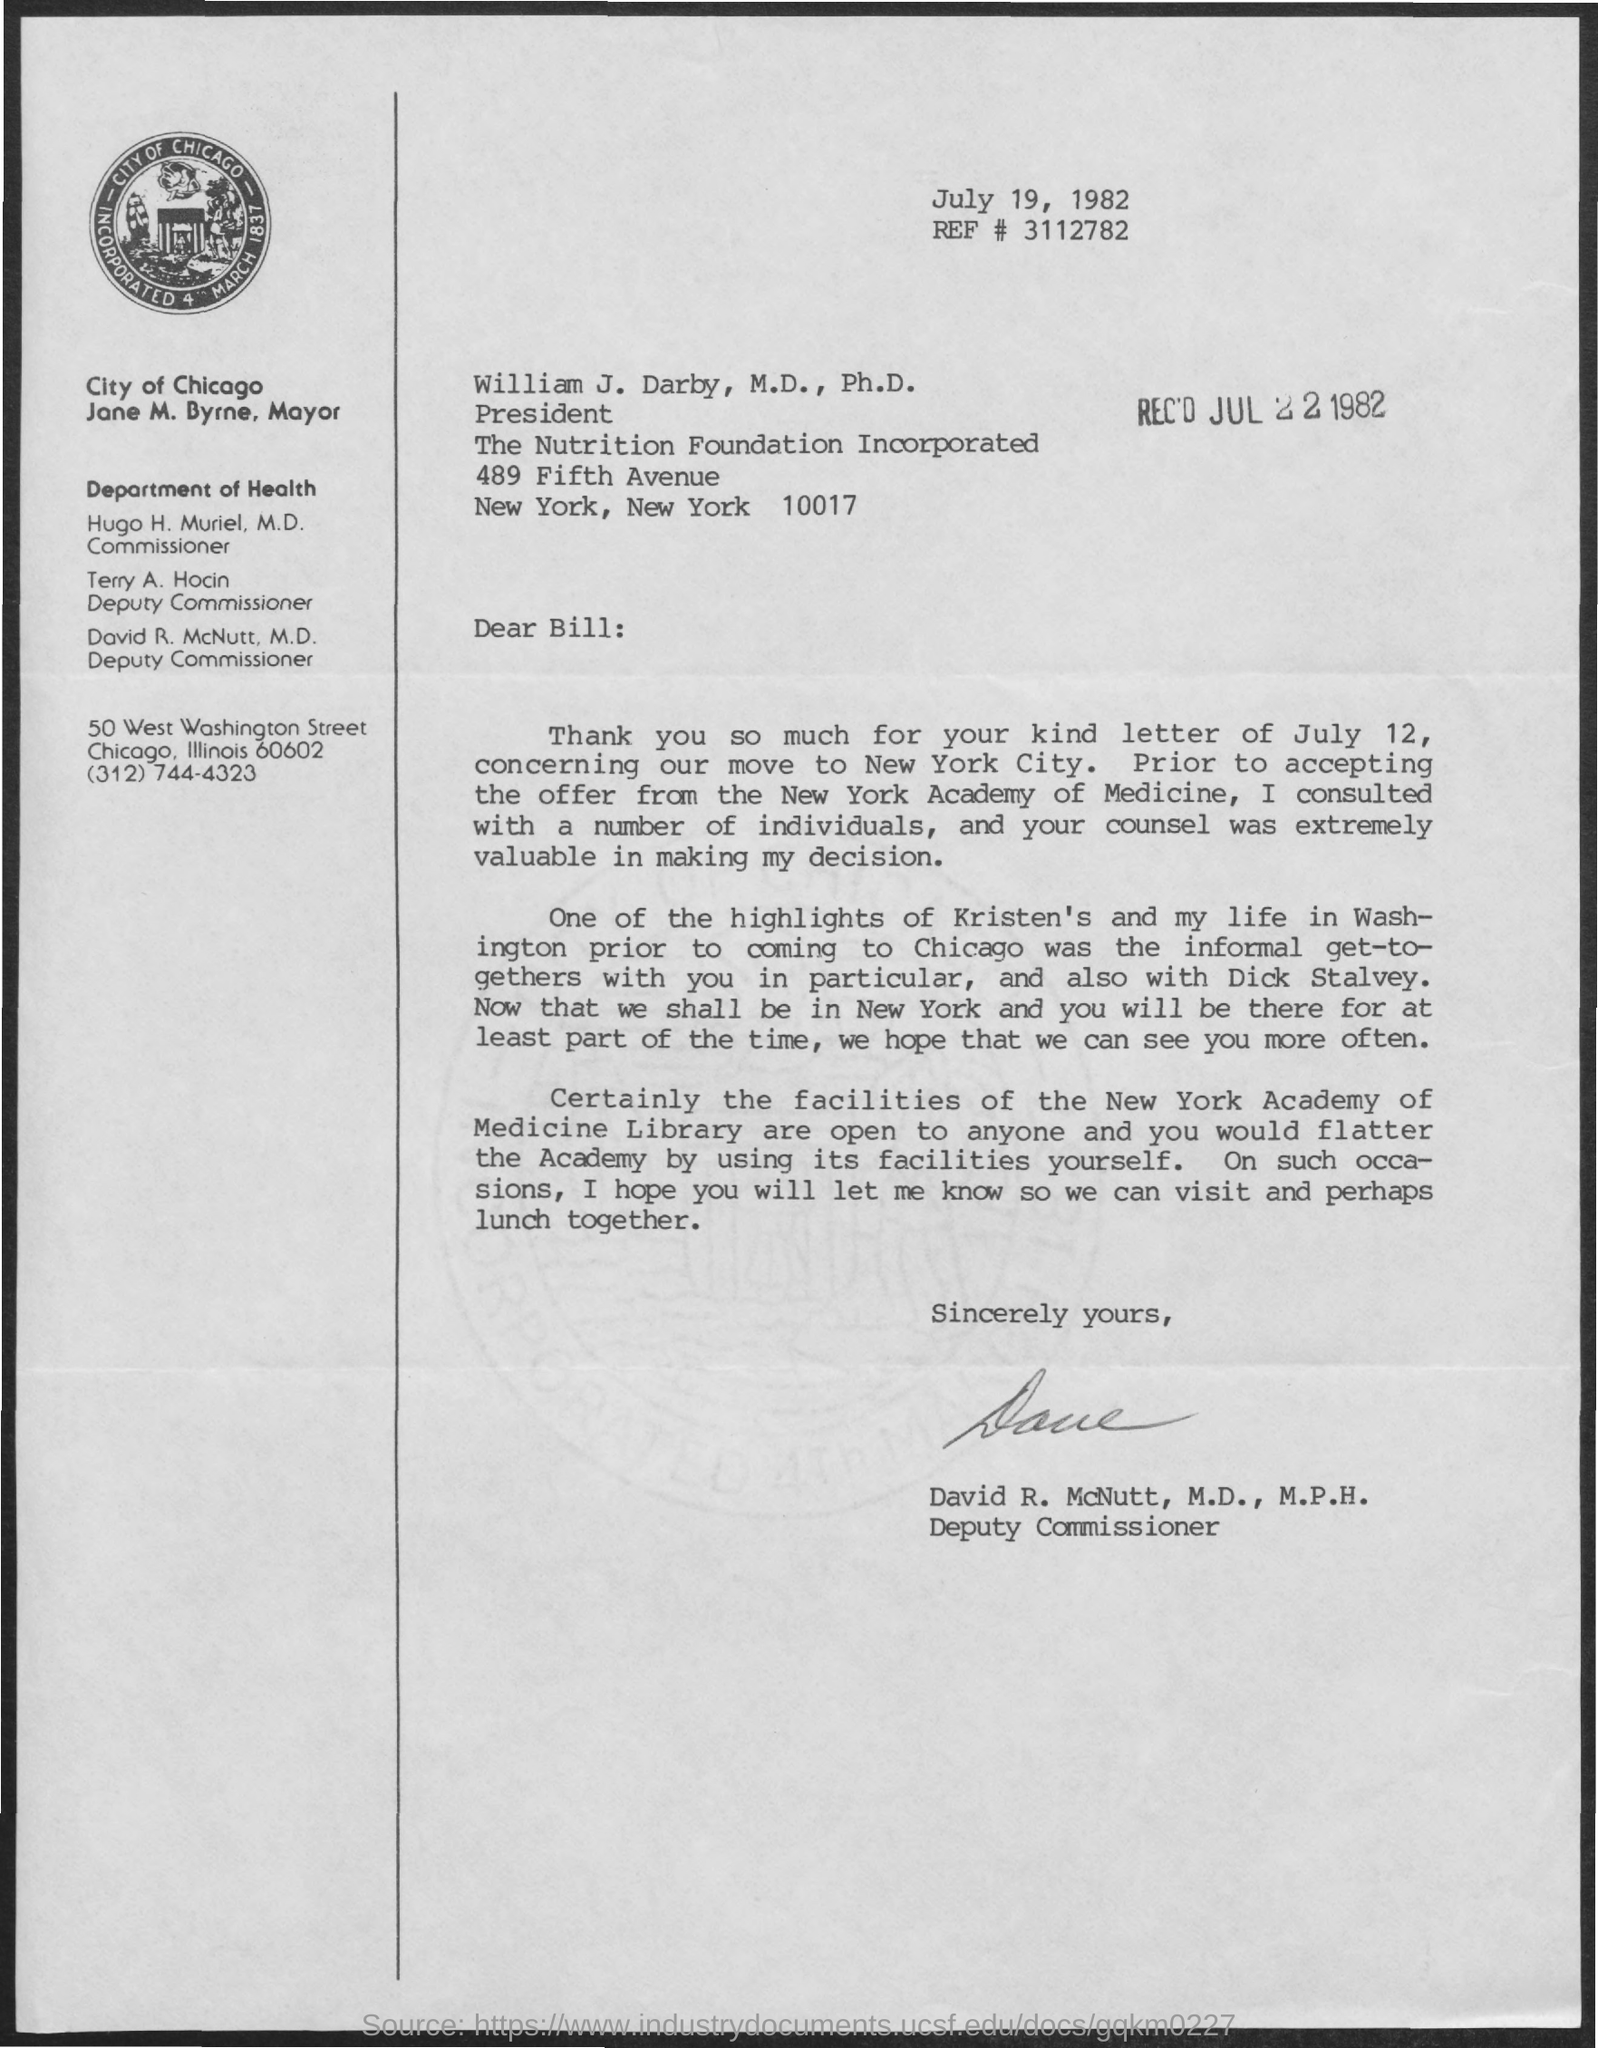Specify some key components in this picture. The letter was received on July 22, 1982. The reference number written in the letter is #3112782 with multiple digits. David R. McNutt holds the designation of Deputy Commissioner. The current commissioner of the Department of Health is Hugo H. Muriel. The letter was written on July 19, 1982. 